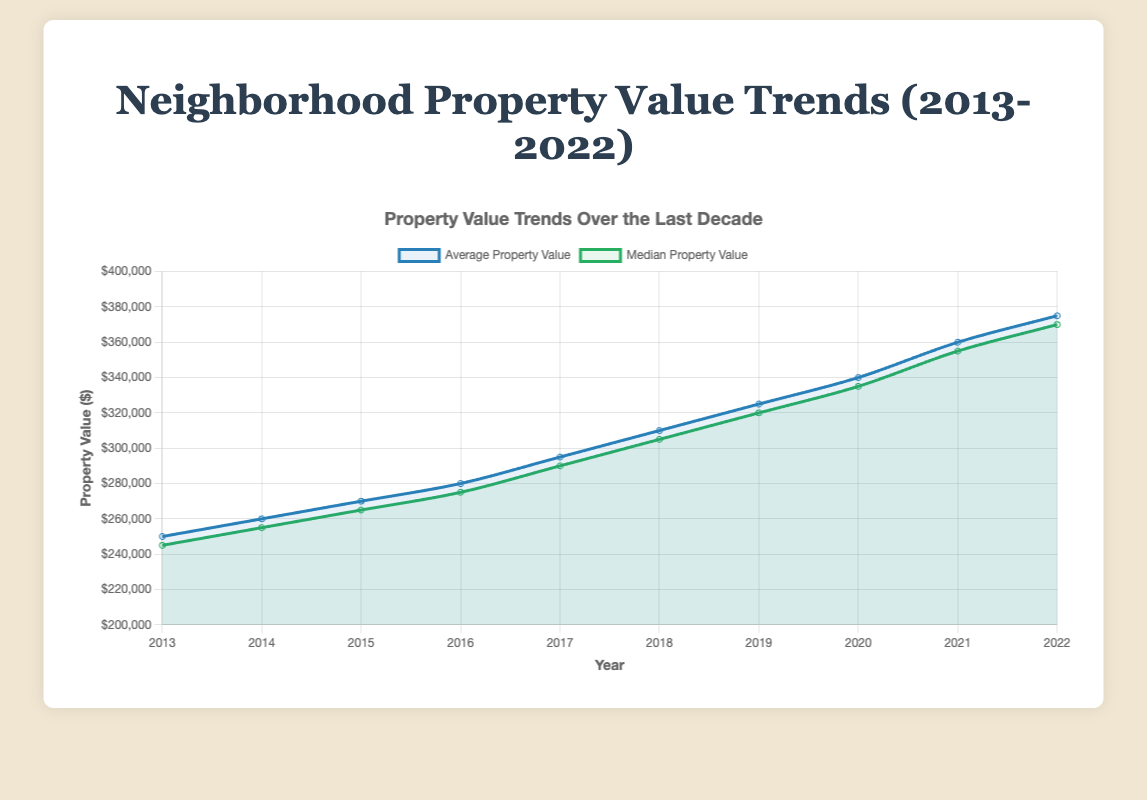What is the average property value in 2017? To find the average property value for the year 2017, refer to the dataset and locate the value listed for that year. In the dataset, it's given as $295,000
Answer: $295,000 Between which years did the median property value see the highest increase? To find this, look at the median property values for each year and compare the differences between consecutive years. The highest increase is from 2021 to 2022 ($355,000 to $370,000)
Answer: 2021 to 2022 In which year was the property count the lowest? Check the property counts for each year and find the minimum value. The year with the lowest property count is 2013, with 40 properties
Answer: 2013 In 2020, how much higher was the average property value compared to 2013? Find the average property values for 2020 and 2013 from the dataset. Subtract the 2013 value from the 2020 value: $340,000 - $250,000 = $90,000
Answer: $90,000 How many times did the average property value increase by more than $10,000 from one year to the next? Compare the average property values year-over-year to see how many times the increase was greater than $10,000. The changes are: 2013-2014 ($10,000), 2014-2015 ($10,000), 2015-2016 ($10,000), 2016-2017 ($15,000), 2017-2018 ($15,000), 2018-2019 ($15,000), 2019-2020 ($15,000), 2020-2021 ($20,000), and 2021-2022 ($15,000), making 8 times total
Answer: 8 Which year had the smallest difference between the average and median property values? Calculate the differences between the average and median property values for each year and find the smallest difference. For 2013 it's $5,000, 2014 it's $5,000, for 2015 it's $5,000, for 2016 it's $5,000, for 2017 it's $5,000, for 2018 it's $5,000, for 2019 it's $5,000, for 2020 it's $5,000, for 2021 it's $5,000, and for 2022 it's $5,000, thus, all differences are the same
Answer: 2013-2022 Which line on the chart represents the median property value? The chart has two lines: one labeled "Average Property Value" and the other "Median Property Value". The line representing the median property value is the one labeled as such, typically shown in a different color (green in this chart)
Answer: The green line 